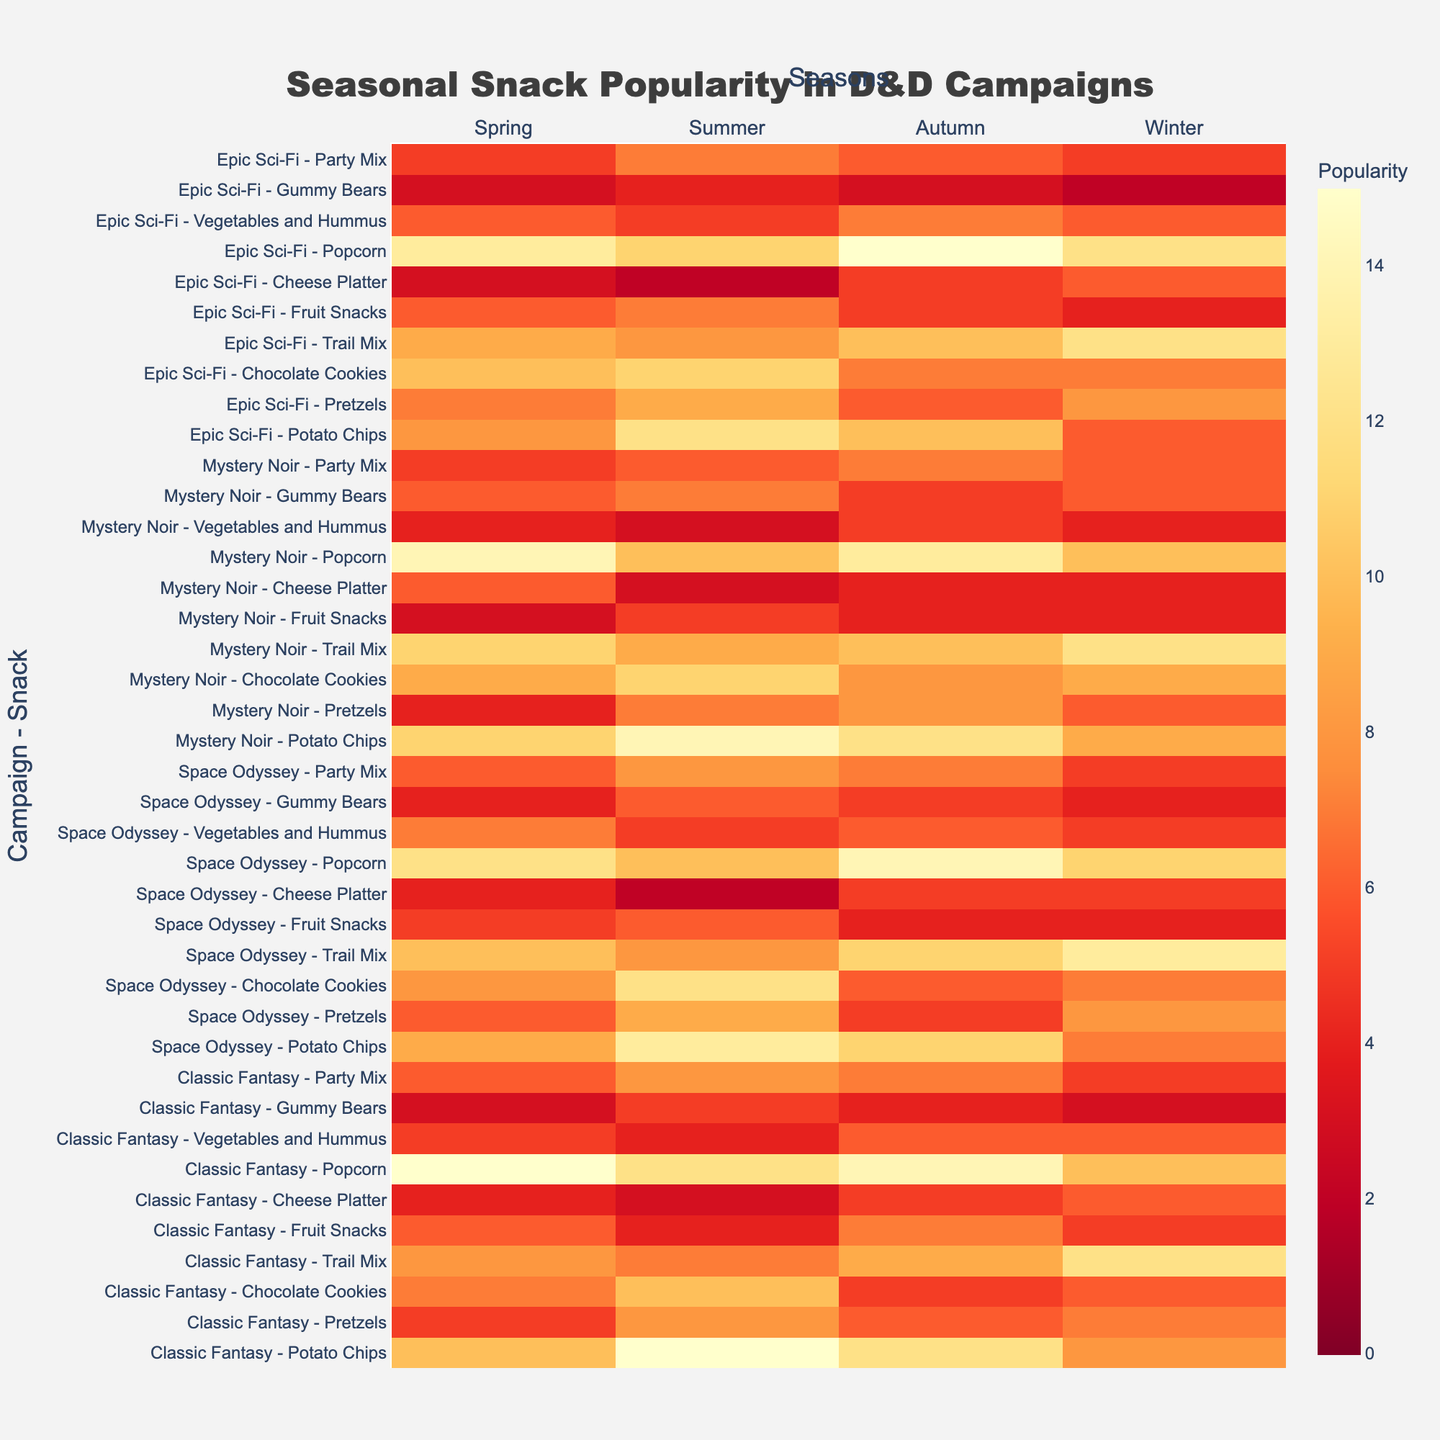What is the title of the heatmap? The title can be seen at the top of the figure.
Answer: Seasonal Snack Popularity in D&D Campaigns How many different campaigns are represented in the heatmap? The number of campaigns can be counted by noting the distinct campaign names listed on the y-axis.
Answer: 4 Which season has the highest popularity for Potato Chips in the 'Classic Fantasy' campaign? Locate the 'Classic Fantasy - Potato Chips' row and find the highest value in that row.
Answer: Summer How does the popularity of Chocolate Cookies in 'Space Odyssey' compare between Spring and Winter? Compare the values for Chocolate Cookies in 'Space Odyssey' for Spring and Winter. The value for Spring is 8 and for Winter is 7.
Answer: Spring is higher What is the difference in popularity of Gummy Bears between the 'Epic Sci-Fi' and 'Mystery Noir' campaigns during Summer? Find the values for Gummy Bears during Summer for both campaigns and subtract one from the other. 'Epic Sci-Fi' has 4 and 'Mystery Noir' has 7. 7 - 4 gives the difference.
Answer: 3 Which snack had the lowest popularity in 'Mystery Noir' during Autumn? Find the row corresponding to 'Mystery Noir - Autumn' and locate the smallest value within it.
Answer: Cheese Platter In which season is Trail Mix most popular in 'Epic Sci-Fi' campaign? Check the values for Trail Mix in the 'Epic Sci-Fi' row for each season to find the highest value.
Answer: Winter Compare the popularity of Popcorn in 'Classic Fantasy' and 'Mystery Noir' during Autumn. Which campaign has a higher popularity? Find the values for Popcorn during Autumn for both campaigns. 'Classic Fantasy' has 14 and 'Mystery Noir' has 13.
Answer: Classic Fantasy How does the average popularity of Pretzels compare between 'Space Odyssey' and 'Mystery Noir'? Calculate the average popularity of Pretzels across all seasons for both campaigns and compare them. 'Space Odyssey' averages to (6 + 9 + 5 + 8) / 4 = 7, 'Mystery Noir' averages to (4 + 7 + 8 + 6) / 4 = 6.25.
Answer: Space Odyssey higher Which campaign and season combination had the highest overall popularity for any snack? Scan the heatmap for the highest value overall, which represents the highest popularity for any snack in a particular campaign and season.
Answer: Classic Fantasy - Potato Chips in Summer 